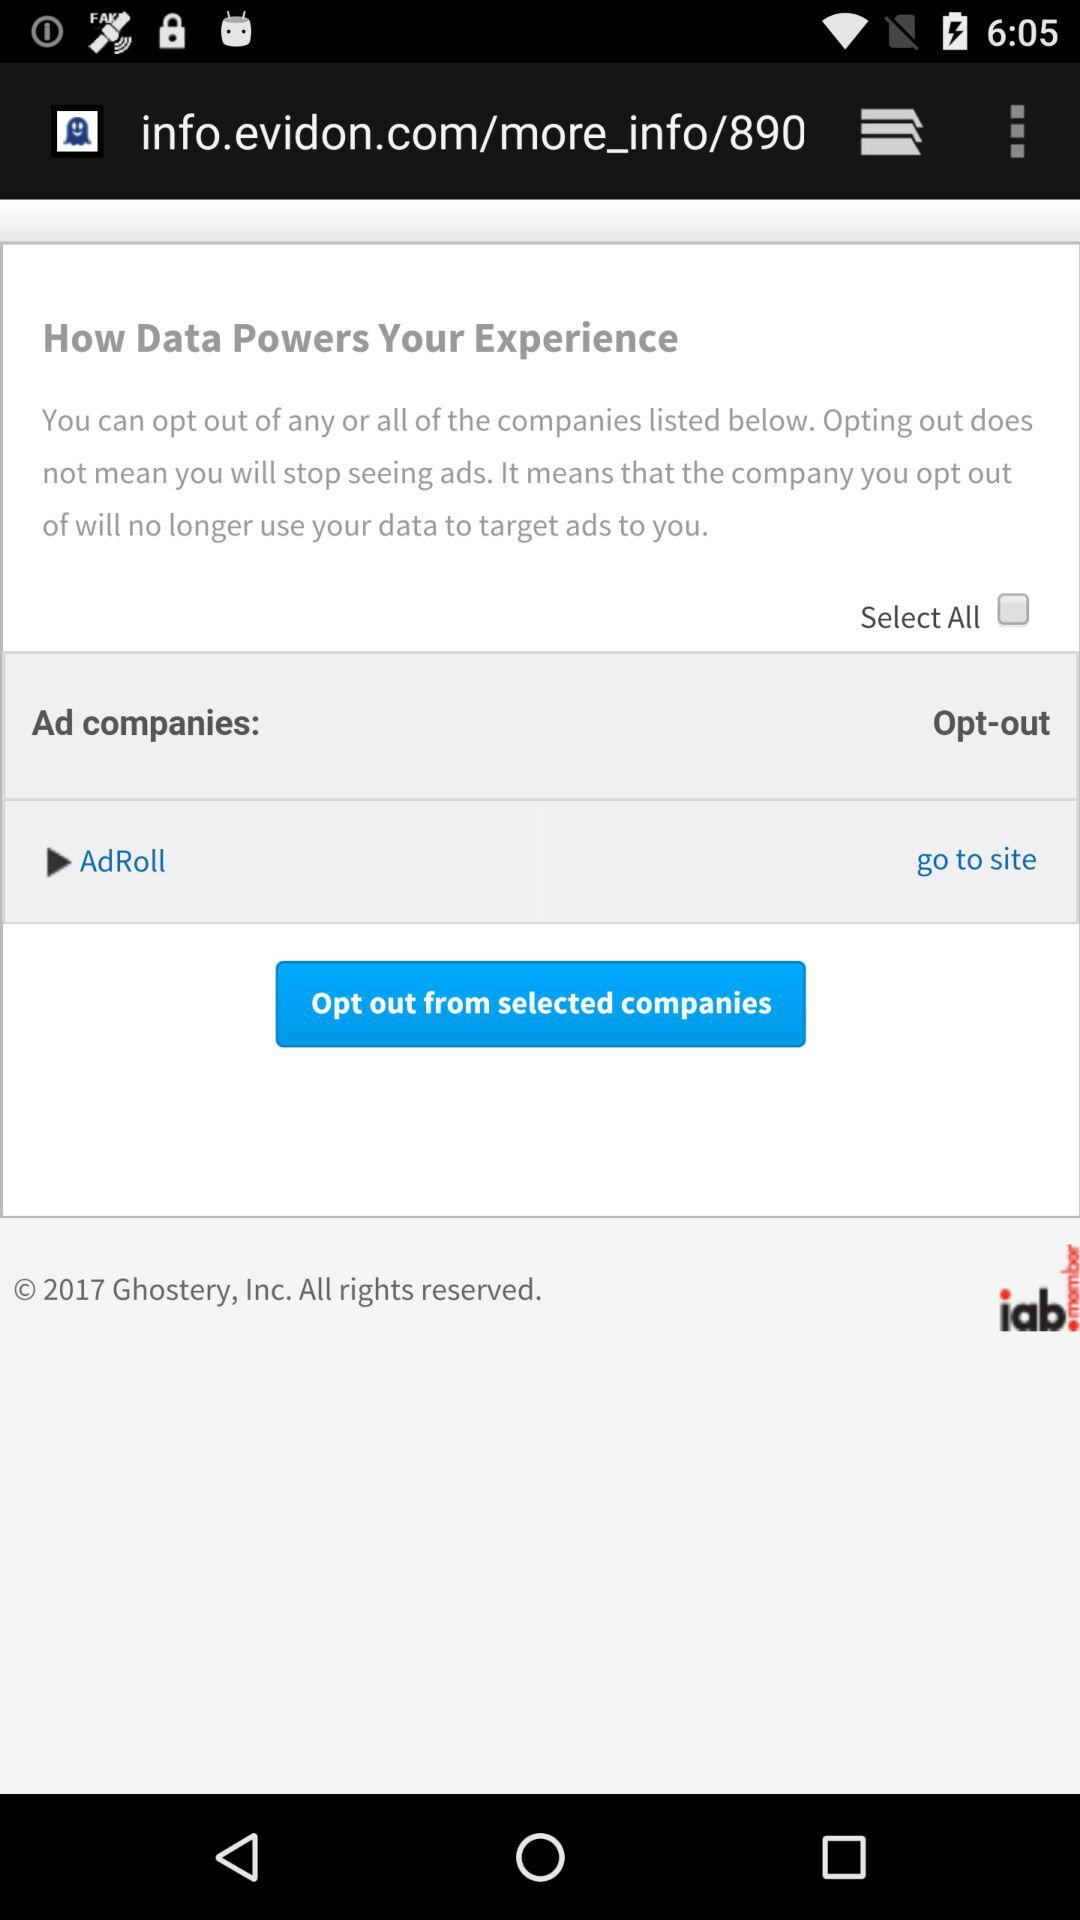What is the status of select all? The status is "off". 